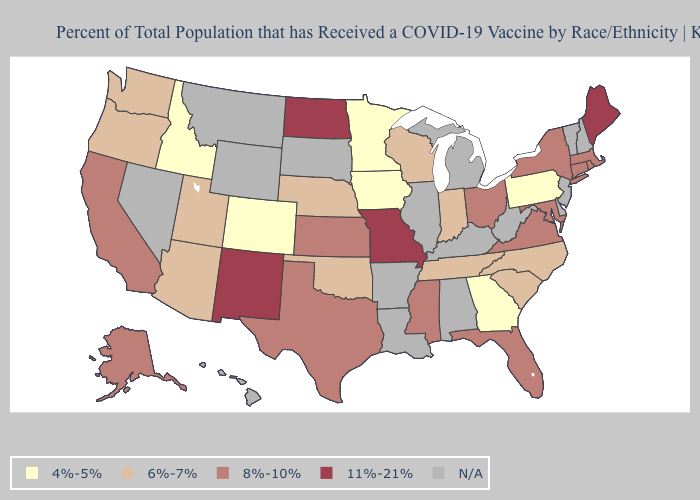Among the states that border Alabama , does Georgia have the highest value?
Answer briefly. No. Which states have the highest value in the USA?
Write a very short answer. Maine, Missouri, New Mexico, North Dakota. What is the value of North Dakota?
Answer briefly. 11%-21%. Is the legend a continuous bar?
Concise answer only. No. Does Missouri have the lowest value in the MidWest?
Be succinct. No. Name the states that have a value in the range 8%-10%?
Write a very short answer. Alaska, California, Connecticut, Florida, Kansas, Maryland, Massachusetts, Mississippi, New York, Ohio, Rhode Island, Texas, Virginia. Name the states that have a value in the range 8%-10%?
Be succinct. Alaska, California, Connecticut, Florida, Kansas, Maryland, Massachusetts, Mississippi, New York, Ohio, Rhode Island, Texas, Virginia. Which states have the lowest value in the USA?
Give a very brief answer. Colorado, Georgia, Idaho, Iowa, Minnesota, Pennsylvania. Does the first symbol in the legend represent the smallest category?
Give a very brief answer. Yes. What is the highest value in the USA?
Concise answer only. 11%-21%. What is the value of Washington?
Answer briefly. 6%-7%. What is the value of New Jersey?
Short answer required. N/A. What is the value of North Carolina?
Concise answer only. 6%-7%. Among the states that border Utah , does New Mexico have the highest value?
Short answer required. Yes. 